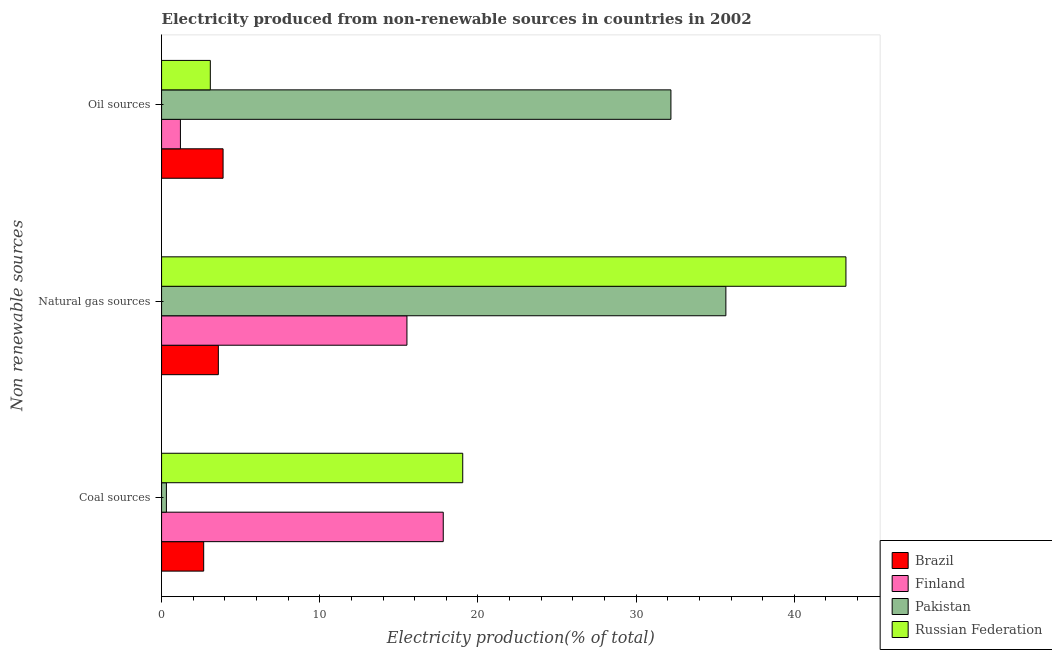How many groups of bars are there?
Offer a terse response. 3. Are the number of bars on each tick of the Y-axis equal?
Ensure brevity in your answer.  Yes. What is the label of the 3rd group of bars from the top?
Provide a short and direct response. Coal sources. What is the percentage of electricity produced by coal in Finland?
Keep it short and to the point. 17.81. Across all countries, what is the maximum percentage of electricity produced by oil sources?
Your answer should be compact. 32.2. Across all countries, what is the minimum percentage of electricity produced by coal?
Offer a terse response. 0.31. In which country was the percentage of electricity produced by coal maximum?
Give a very brief answer. Russian Federation. What is the total percentage of electricity produced by coal in the graph?
Ensure brevity in your answer.  39.81. What is the difference between the percentage of electricity produced by natural gas in Finland and that in Russian Federation?
Your answer should be compact. -27.75. What is the difference between the percentage of electricity produced by natural gas in Finland and the percentage of electricity produced by oil sources in Pakistan?
Offer a terse response. -16.69. What is the average percentage of electricity produced by coal per country?
Offer a terse response. 9.95. What is the difference between the percentage of electricity produced by oil sources and percentage of electricity produced by natural gas in Brazil?
Your answer should be compact. 0.3. What is the ratio of the percentage of electricity produced by natural gas in Brazil to that in Finland?
Keep it short and to the point. 0.23. Is the percentage of electricity produced by coal in Brazil less than that in Russian Federation?
Offer a very short reply. Yes. Is the difference between the percentage of electricity produced by oil sources in Russian Federation and Pakistan greater than the difference between the percentage of electricity produced by natural gas in Russian Federation and Pakistan?
Offer a very short reply. No. What is the difference between the highest and the second highest percentage of electricity produced by natural gas?
Keep it short and to the point. 7.59. What is the difference between the highest and the lowest percentage of electricity produced by oil sources?
Make the answer very short. 31.01. What does the 1st bar from the top in Oil sources represents?
Your answer should be very brief. Russian Federation. Is it the case that in every country, the sum of the percentage of electricity produced by coal and percentage of electricity produced by natural gas is greater than the percentage of electricity produced by oil sources?
Offer a very short reply. Yes. How many bars are there?
Keep it short and to the point. 12. How many countries are there in the graph?
Your answer should be very brief. 4. What is the difference between two consecutive major ticks on the X-axis?
Keep it short and to the point. 10. Does the graph contain any zero values?
Your response must be concise. No. How many legend labels are there?
Your answer should be compact. 4. How are the legend labels stacked?
Provide a short and direct response. Vertical. What is the title of the graph?
Ensure brevity in your answer.  Electricity produced from non-renewable sources in countries in 2002. Does "European Union" appear as one of the legend labels in the graph?
Offer a terse response. No. What is the label or title of the X-axis?
Ensure brevity in your answer.  Electricity production(% of total). What is the label or title of the Y-axis?
Your answer should be very brief. Non renewable sources. What is the Electricity production(% of total) of Brazil in Coal sources?
Your response must be concise. 2.66. What is the Electricity production(% of total) of Finland in Coal sources?
Give a very brief answer. 17.81. What is the Electricity production(% of total) of Pakistan in Coal sources?
Offer a very short reply. 0.31. What is the Electricity production(% of total) of Russian Federation in Coal sources?
Your answer should be compact. 19.04. What is the Electricity production(% of total) in Brazil in Natural gas sources?
Offer a terse response. 3.59. What is the Electricity production(% of total) in Finland in Natural gas sources?
Make the answer very short. 15.51. What is the Electricity production(% of total) in Pakistan in Natural gas sources?
Offer a terse response. 35.67. What is the Electricity production(% of total) in Russian Federation in Natural gas sources?
Give a very brief answer. 43.26. What is the Electricity production(% of total) of Brazil in Oil sources?
Offer a very short reply. 3.89. What is the Electricity production(% of total) in Finland in Oil sources?
Offer a terse response. 1.19. What is the Electricity production(% of total) in Pakistan in Oil sources?
Provide a short and direct response. 32.2. What is the Electricity production(% of total) of Russian Federation in Oil sources?
Give a very brief answer. 3.08. Across all Non renewable sources, what is the maximum Electricity production(% of total) in Brazil?
Offer a terse response. 3.89. Across all Non renewable sources, what is the maximum Electricity production(% of total) in Finland?
Your answer should be very brief. 17.81. Across all Non renewable sources, what is the maximum Electricity production(% of total) in Pakistan?
Keep it short and to the point. 35.67. Across all Non renewable sources, what is the maximum Electricity production(% of total) in Russian Federation?
Provide a short and direct response. 43.26. Across all Non renewable sources, what is the minimum Electricity production(% of total) in Brazil?
Your answer should be very brief. 2.66. Across all Non renewable sources, what is the minimum Electricity production(% of total) in Finland?
Ensure brevity in your answer.  1.19. Across all Non renewable sources, what is the minimum Electricity production(% of total) in Pakistan?
Offer a terse response. 0.31. Across all Non renewable sources, what is the minimum Electricity production(% of total) in Russian Federation?
Offer a terse response. 3.08. What is the total Electricity production(% of total) of Brazil in the graph?
Ensure brevity in your answer.  10.14. What is the total Electricity production(% of total) in Finland in the graph?
Give a very brief answer. 34.51. What is the total Electricity production(% of total) in Pakistan in the graph?
Make the answer very short. 68.18. What is the total Electricity production(% of total) of Russian Federation in the graph?
Your response must be concise. 65.38. What is the difference between the Electricity production(% of total) in Brazil in Coal sources and that in Natural gas sources?
Offer a very short reply. -0.93. What is the difference between the Electricity production(% of total) in Finland in Coal sources and that in Natural gas sources?
Make the answer very short. 2.29. What is the difference between the Electricity production(% of total) in Pakistan in Coal sources and that in Natural gas sources?
Keep it short and to the point. -35.37. What is the difference between the Electricity production(% of total) of Russian Federation in Coal sources and that in Natural gas sources?
Keep it short and to the point. -24.22. What is the difference between the Electricity production(% of total) of Brazil in Coal sources and that in Oil sources?
Ensure brevity in your answer.  -1.23. What is the difference between the Electricity production(% of total) in Finland in Coal sources and that in Oil sources?
Offer a terse response. 16.61. What is the difference between the Electricity production(% of total) in Pakistan in Coal sources and that in Oil sources?
Ensure brevity in your answer.  -31.89. What is the difference between the Electricity production(% of total) in Russian Federation in Coal sources and that in Oil sources?
Your response must be concise. 15.96. What is the difference between the Electricity production(% of total) of Brazil in Natural gas sources and that in Oil sources?
Give a very brief answer. -0.3. What is the difference between the Electricity production(% of total) in Finland in Natural gas sources and that in Oil sources?
Your answer should be very brief. 14.32. What is the difference between the Electricity production(% of total) of Pakistan in Natural gas sources and that in Oil sources?
Offer a terse response. 3.47. What is the difference between the Electricity production(% of total) in Russian Federation in Natural gas sources and that in Oil sources?
Ensure brevity in your answer.  40.18. What is the difference between the Electricity production(% of total) of Brazil in Coal sources and the Electricity production(% of total) of Finland in Natural gas sources?
Provide a short and direct response. -12.85. What is the difference between the Electricity production(% of total) in Brazil in Coal sources and the Electricity production(% of total) in Pakistan in Natural gas sources?
Your answer should be compact. -33.01. What is the difference between the Electricity production(% of total) of Brazil in Coal sources and the Electricity production(% of total) of Russian Federation in Natural gas sources?
Your answer should be compact. -40.6. What is the difference between the Electricity production(% of total) of Finland in Coal sources and the Electricity production(% of total) of Pakistan in Natural gas sources?
Keep it short and to the point. -17.87. What is the difference between the Electricity production(% of total) in Finland in Coal sources and the Electricity production(% of total) in Russian Federation in Natural gas sources?
Ensure brevity in your answer.  -25.46. What is the difference between the Electricity production(% of total) of Pakistan in Coal sources and the Electricity production(% of total) of Russian Federation in Natural gas sources?
Your response must be concise. -42.96. What is the difference between the Electricity production(% of total) in Brazil in Coal sources and the Electricity production(% of total) in Finland in Oil sources?
Your answer should be compact. 1.47. What is the difference between the Electricity production(% of total) in Brazil in Coal sources and the Electricity production(% of total) in Pakistan in Oil sources?
Provide a succinct answer. -29.54. What is the difference between the Electricity production(% of total) in Brazil in Coal sources and the Electricity production(% of total) in Russian Federation in Oil sources?
Offer a terse response. -0.42. What is the difference between the Electricity production(% of total) in Finland in Coal sources and the Electricity production(% of total) in Pakistan in Oil sources?
Provide a short and direct response. -14.39. What is the difference between the Electricity production(% of total) of Finland in Coal sources and the Electricity production(% of total) of Russian Federation in Oil sources?
Ensure brevity in your answer.  14.72. What is the difference between the Electricity production(% of total) of Pakistan in Coal sources and the Electricity production(% of total) of Russian Federation in Oil sources?
Keep it short and to the point. -2.78. What is the difference between the Electricity production(% of total) of Brazil in Natural gas sources and the Electricity production(% of total) of Finland in Oil sources?
Give a very brief answer. 2.4. What is the difference between the Electricity production(% of total) of Brazil in Natural gas sources and the Electricity production(% of total) of Pakistan in Oil sources?
Give a very brief answer. -28.61. What is the difference between the Electricity production(% of total) in Brazil in Natural gas sources and the Electricity production(% of total) in Russian Federation in Oil sources?
Your answer should be compact. 0.51. What is the difference between the Electricity production(% of total) of Finland in Natural gas sources and the Electricity production(% of total) of Pakistan in Oil sources?
Offer a very short reply. -16.69. What is the difference between the Electricity production(% of total) in Finland in Natural gas sources and the Electricity production(% of total) in Russian Federation in Oil sources?
Your answer should be compact. 12.43. What is the difference between the Electricity production(% of total) in Pakistan in Natural gas sources and the Electricity production(% of total) in Russian Federation in Oil sources?
Offer a terse response. 32.59. What is the average Electricity production(% of total) in Brazil per Non renewable sources?
Keep it short and to the point. 3.38. What is the average Electricity production(% of total) in Finland per Non renewable sources?
Make the answer very short. 11.5. What is the average Electricity production(% of total) in Pakistan per Non renewable sources?
Make the answer very short. 22.73. What is the average Electricity production(% of total) in Russian Federation per Non renewable sources?
Offer a terse response. 21.79. What is the difference between the Electricity production(% of total) in Brazil and Electricity production(% of total) in Finland in Coal sources?
Offer a terse response. -15.14. What is the difference between the Electricity production(% of total) in Brazil and Electricity production(% of total) in Pakistan in Coal sources?
Give a very brief answer. 2.36. What is the difference between the Electricity production(% of total) in Brazil and Electricity production(% of total) in Russian Federation in Coal sources?
Your answer should be very brief. -16.38. What is the difference between the Electricity production(% of total) of Finland and Electricity production(% of total) of Pakistan in Coal sources?
Your answer should be very brief. 17.5. What is the difference between the Electricity production(% of total) of Finland and Electricity production(% of total) of Russian Federation in Coal sources?
Ensure brevity in your answer.  -1.23. What is the difference between the Electricity production(% of total) in Pakistan and Electricity production(% of total) in Russian Federation in Coal sources?
Provide a succinct answer. -18.73. What is the difference between the Electricity production(% of total) in Brazil and Electricity production(% of total) in Finland in Natural gas sources?
Your answer should be very brief. -11.92. What is the difference between the Electricity production(% of total) in Brazil and Electricity production(% of total) in Pakistan in Natural gas sources?
Provide a succinct answer. -32.08. What is the difference between the Electricity production(% of total) in Brazil and Electricity production(% of total) in Russian Federation in Natural gas sources?
Provide a succinct answer. -39.67. What is the difference between the Electricity production(% of total) in Finland and Electricity production(% of total) in Pakistan in Natural gas sources?
Give a very brief answer. -20.16. What is the difference between the Electricity production(% of total) in Finland and Electricity production(% of total) in Russian Federation in Natural gas sources?
Ensure brevity in your answer.  -27.75. What is the difference between the Electricity production(% of total) in Pakistan and Electricity production(% of total) in Russian Federation in Natural gas sources?
Make the answer very short. -7.59. What is the difference between the Electricity production(% of total) in Brazil and Electricity production(% of total) in Finland in Oil sources?
Your response must be concise. 2.7. What is the difference between the Electricity production(% of total) of Brazil and Electricity production(% of total) of Pakistan in Oil sources?
Provide a short and direct response. -28.31. What is the difference between the Electricity production(% of total) of Brazil and Electricity production(% of total) of Russian Federation in Oil sources?
Offer a very short reply. 0.81. What is the difference between the Electricity production(% of total) of Finland and Electricity production(% of total) of Pakistan in Oil sources?
Make the answer very short. -31.01. What is the difference between the Electricity production(% of total) of Finland and Electricity production(% of total) of Russian Federation in Oil sources?
Your response must be concise. -1.89. What is the difference between the Electricity production(% of total) of Pakistan and Electricity production(% of total) of Russian Federation in Oil sources?
Your answer should be compact. 29.12. What is the ratio of the Electricity production(% of total) in Brazil in Coal sources to that in Natural gas sources?
Make the answer very short. 0.74. What is the ratio of the Electricity production(% of total) of Finland in Coal sources to that in Natural gas sources?
Offer a very short reply. 1.15. What is the ratio of the Electricity production(% of total) of Pakistan in Coal sources to that in Natural gas sources?
Make the answer very short. 0.01. What is the ratio of the Electricity production(% of total) in Russian Federation in Coal sources to that in Natural gas sources?
Make the answer very short. 0.44. What is the ratio of the Electricity production(% of total) of Brazil in Coal sources to that in Oil sources?
Offer a terse response. 0.68. What is the ratio of the Electricity production(% of total) in Finland in Coal sources to that in Oil sources?
Offer a very short reply. 14.94. What is the ratio of the Electricity production(% of total) in Pakistan in Coal sources to that in Oil sources?
Ensure brevity in your answer.  0.01. What is the ratio of the Electricity production(% of total) of Russian Federation in Coal sources to that in Oil sources?
Your answer should be compact. 6.18. What is the ratio of the Electricity production(% of total) in Brazil in Natural gas sources to that in Oil sources?
Your response must be concise. 0.92. What is the ratio of the Electricity production(% of total) in Finland in Natural gas sources to that in Oil sources?
Your answer should be compact. 13.02. What is the ratio of the Electricity production(% of total) of Pakistan in Natural gas sources to that in Oil sources?
Your response must be concise. 1.11. What is the ratio of the Electricity production(% of total) in Russian Federation in Natural gas sources to that in Oil sources?
Ensure brevity in your answer.  14.04. What is the difference between the highest and the second highest Electricity production(% of total) in Brazil?
Keep it short and to the point. 0.3. What is the difference between the highest and the second highest Electricity production(% of total) of Finland?
Provide a short and direct response. 2.29. What is the difference between the highest and the second highest Electricity production(% of total) in Pakistan?
Your answer should be very brief. 3.47. What is the difference between the highest and the second highest Electricity production(% of total) in Russian Federation?
Offer a terse response. 24.22. What is the difference between the highest and the lowest Electricity production(% of total) in Brazil?
Your answer should be very brief. 1.23. What is the difference between the highest and the lowest Electricity production(% of total) of Finland?
Make the answer very short. 16.61. What is the difference between the highest and the lowest Electricity production(% of total) in Pakistan?
Make the answer very short. 35.37. What is the difference between the highest and the lowest Electricity production(% of total) in Russian Federation?
Ensure brevity in your answer.  40.18. 